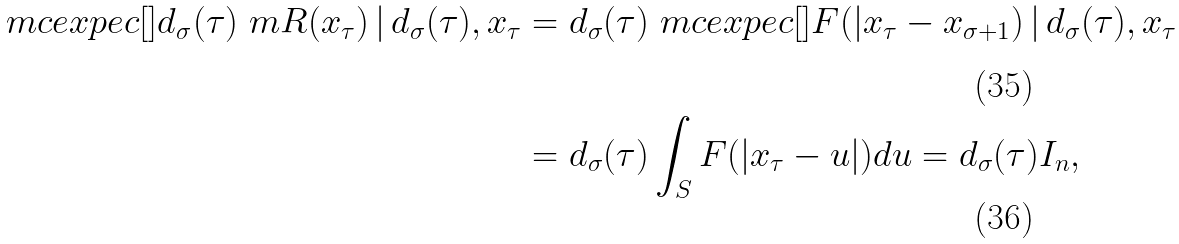<formula> <loc_0><loc_0><loc_500><loc_500>\ m c e x p e c [ ] { d _ { \sigma } ( \tau ) \ m R ( x _ { \tau } ) \, | \, d _ { \sigma } ( \tau ) , x _ { \tau } } & = d _ { \sigma } ( \tau ) \ m c e x p e c [ ] { F ( | x _ { \tau } - x _ { \sigma + 1 } ) \, | \, d _ { \sigma } ( \tau ) , x _ { \tau } } \\ & = d _ { \sigma } ( \tau ) \int _ { S } F ( | x _ { \tau } - u | ) d u = d _ { \sigma } ( \tau ) I _ { n } ,</formula> 